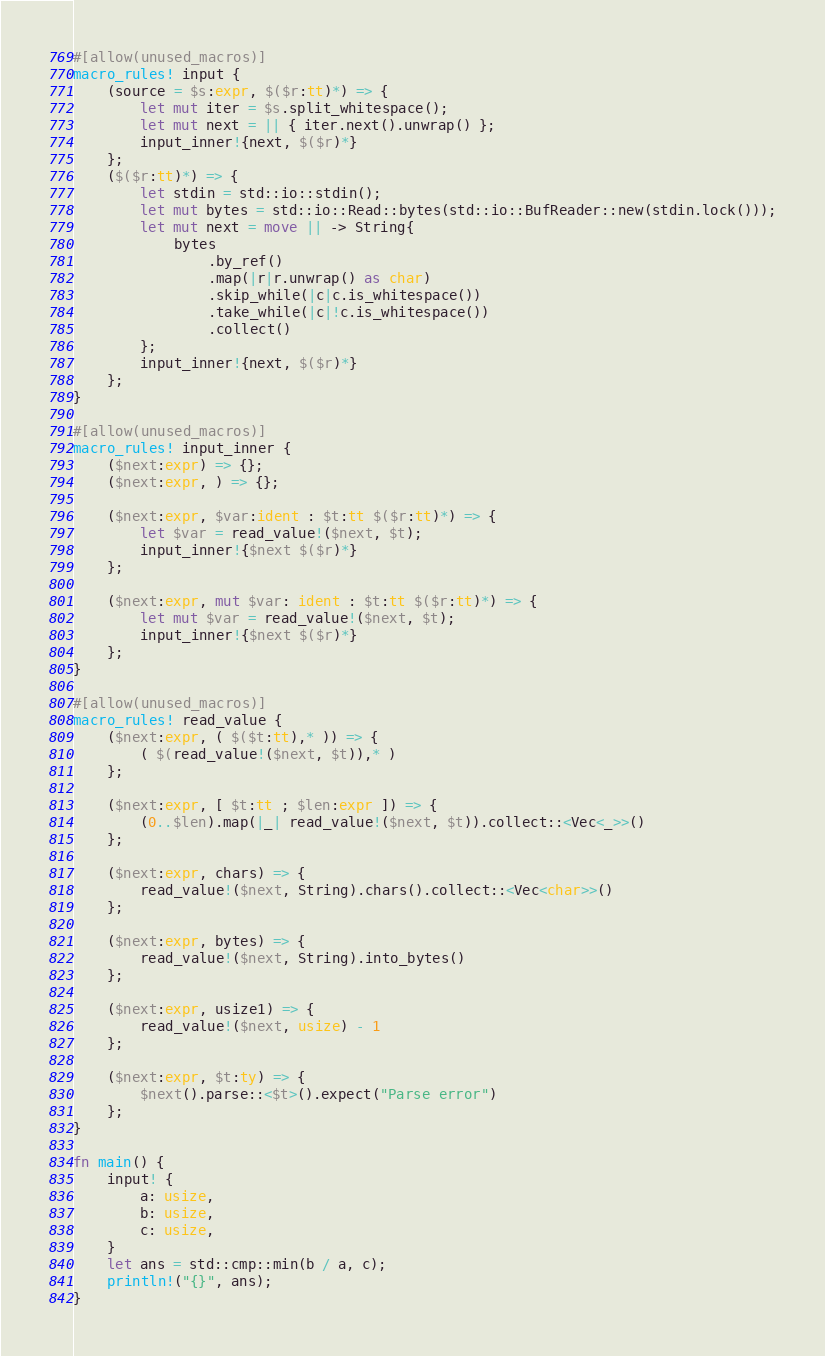Convert code to text. <code><loc_0><loc_0><loc_500><loc_500><_Rust_>#[allow(unused_macros)]
macro_rules! input {
    (source = $s:expr, $($r:tt)*) => {
        let mut iter = $s.split_whitespace();
        let mut next = || { iter.next().unwrap() };
        input_inner!{next, $($r)*}
    };
    ($($r:tt)*) => {
        let stdin = std::io::stdin();
        let mut bytes = std::io::Read::bytes(std::io::BufReader::new(stdin.lock()));
        let mut next = move || -> String{
            bytes
                .by_ref()
                .map(|r|r.unwrap() as char)
                .skip_while(|c|c.is_whitespace())
                .take_while(|c|!c.is_whitespace())
                .collect()
        };
        input_inner!{next, $($r)*}
    };
}

#[allow(unused_macros)]
macro_rules! input_inner {
    ($next:expr) => {};
    ($next:expr, ) => {};

    ($next:expr, $var:ident : $t:tt $($r:tt)*) => {
        let $var = read_value!($next, $t);
        input_inner!{$next $($r)*}
    };

    ($next:expr, mut $var: ident : $t:tt $($r:tt)*) => {
        let mut $var = read_value!($next, $t);
        input_inner!{$next $($r)*}
    };
}

#[allow(unused_macros)]
macro_rules! read_value {
    ($next:expr, ( $($t:tt),* )) => {
        ( $(read_value!($next, $t)),* )
    };

    ($next:expr, [ $t:tt ; $len:expr ]) => {
        (0..$len).map(|_| read_value!($next, $t)).collect::<Vec<_>>()
    };

    ($next:expr, chars) => {
        read_value!($next, String).chars().collect::<Vec<char>>()
    };

    ($next:expr, bytes) => {
        read_value!($next, String).into_bytes()
    };

    ($next:expr, usize1) => {
        read_value!($next, usize) - 1
    };

    ($next:expr, $t:ty) => {
        $next().parse::<$t>().expect("Parse error")
    };
}

fn main() {
    input! {
        a: usize,
        b: usize,
        c: usize,
    }
    let ans = std::cmp::min(b / a, c);
    println!("{}", ans);
}
</code> 